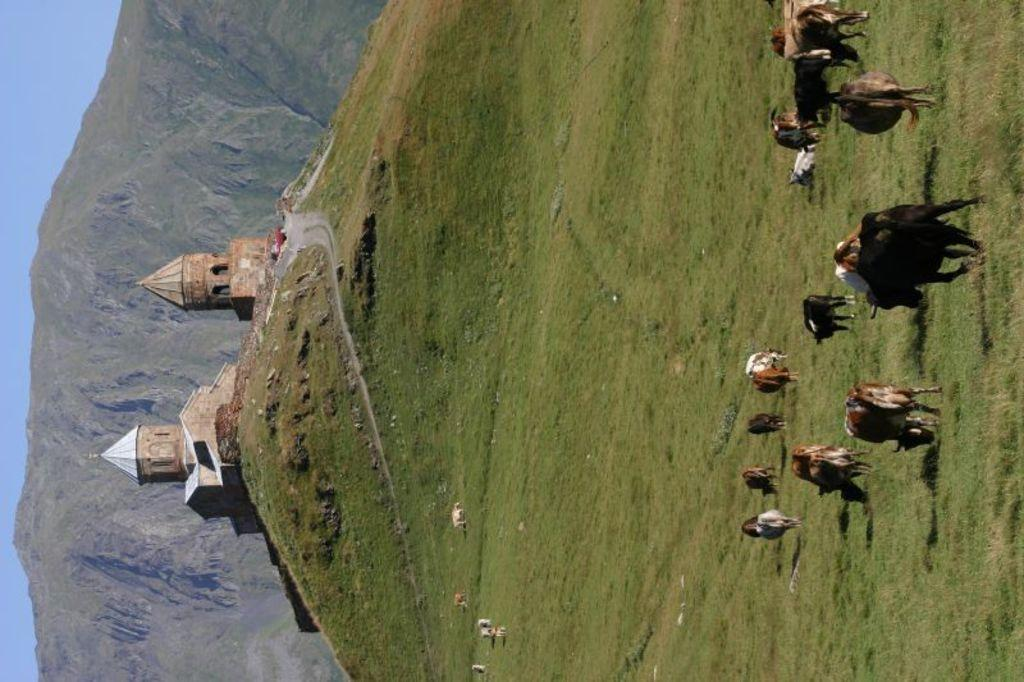What animals are present in the image? There is a group of cows in the image. What are the cows doing in the image? The cows are eating grass. What structure is located on the left side of the image? There is a house on the left side of the image. What type of natural feature can be seen in the image? There are mountains visible in the image. What type of jewel can be seen on the cow's neck in the image? There are no jewels present on the cows in the image; they are simply eating grass. What type of pancake is being prepared on the mountains in the image? There is no pancake or cooking activity present in the image; it features a group of cows eating grass, a house, and mountains. 